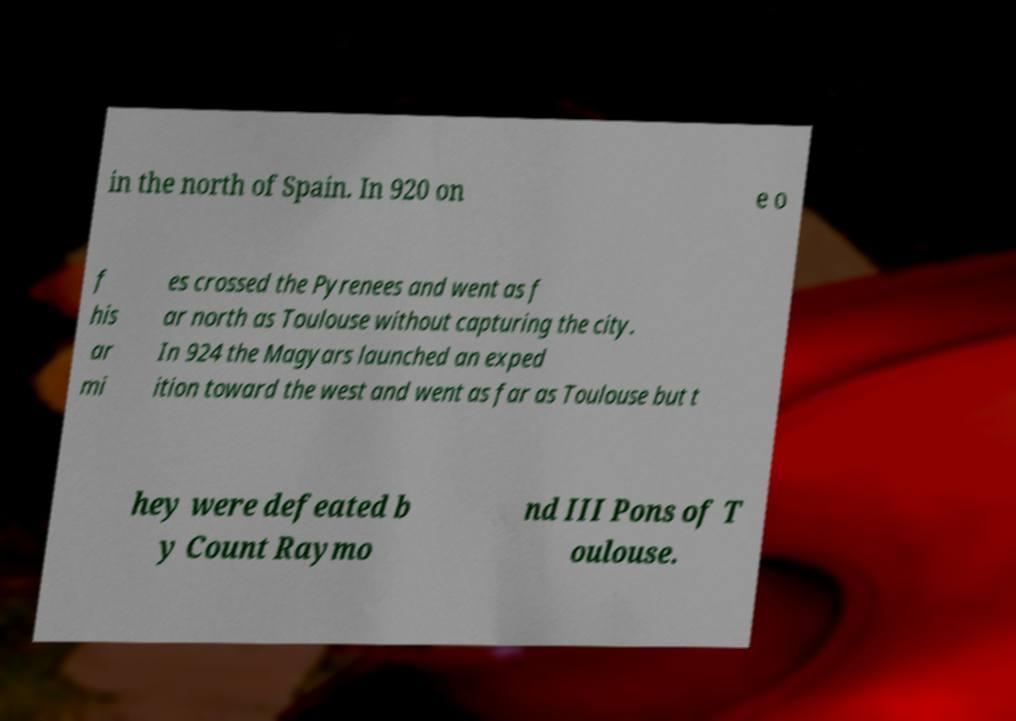For documentation purposes, I need the text within this image transcribed. Could you provide that? in the north of Spain. In 920 on e o f his ar mi es crossed the Pyrenees and went as f ar north as Toulouse without capturing the city. In 924 the Magyars launched an exped ition toward the west and went as far as Toulouse but t hey were defeated b y Count Raymo nd III Pons of T oulouse. 